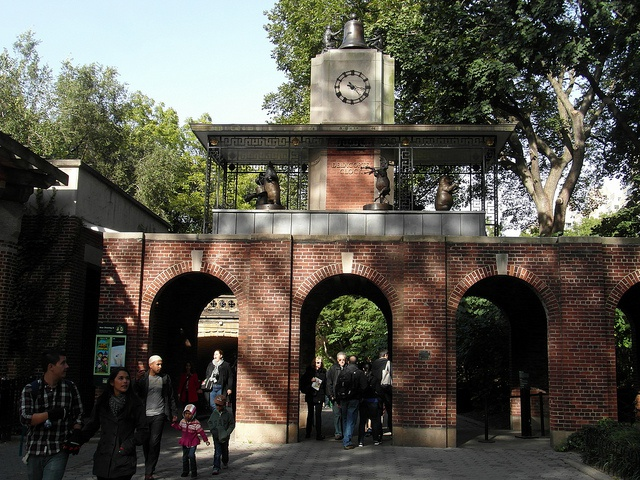Describe the objects in this image and their specific colors. I can see people in lightblue, black, maroon, gray, and purple tones, people in lightblue, black, maroon, brown, and gray tones, people in lightblue, black, gray, darkgray, and maroon tones, people in lightblue, black, gray, blue, and navy tones, and people in lightblue, black, gray, and darkgray tones in this image. 